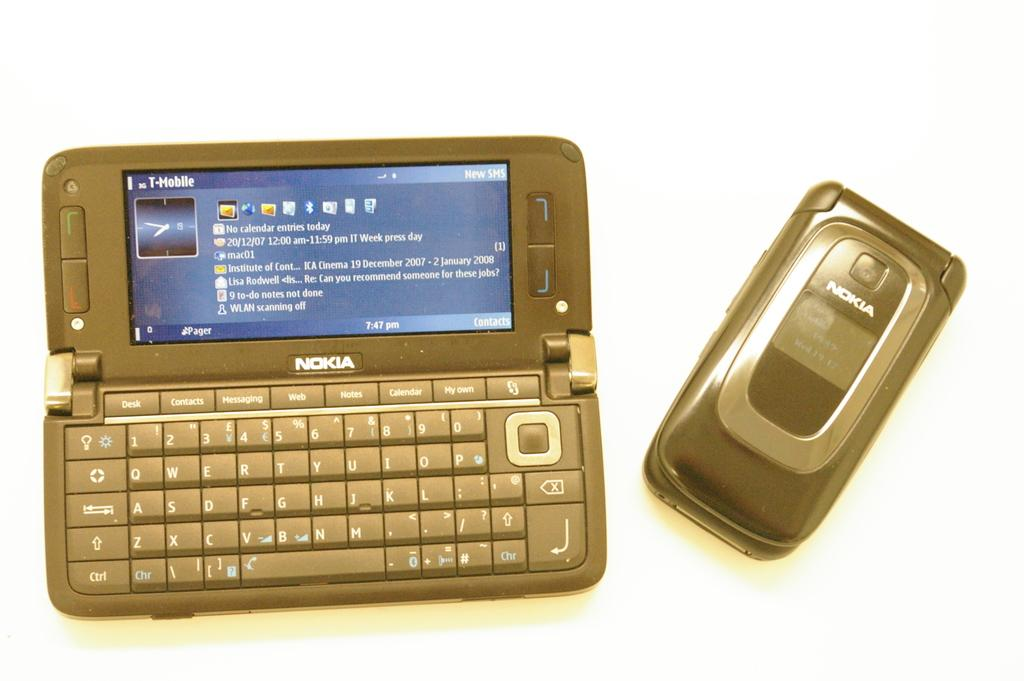<image>
Present a compact description of the photo's key features. a Nokia flip phone with the carrier T Mobile 